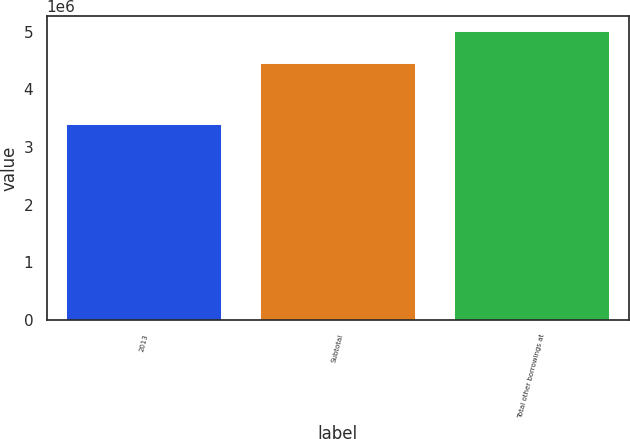Convert chart. <chart><loc_0><loc_0><loc_500><loc_500><bar_chart><fcel>2013<fcel>Subtotal<fcel>Total other borrowings at<nl><fcel>3.40243e+06<fcel>4.45466e+06<fcel>5.0155e+06<nl></chart> 